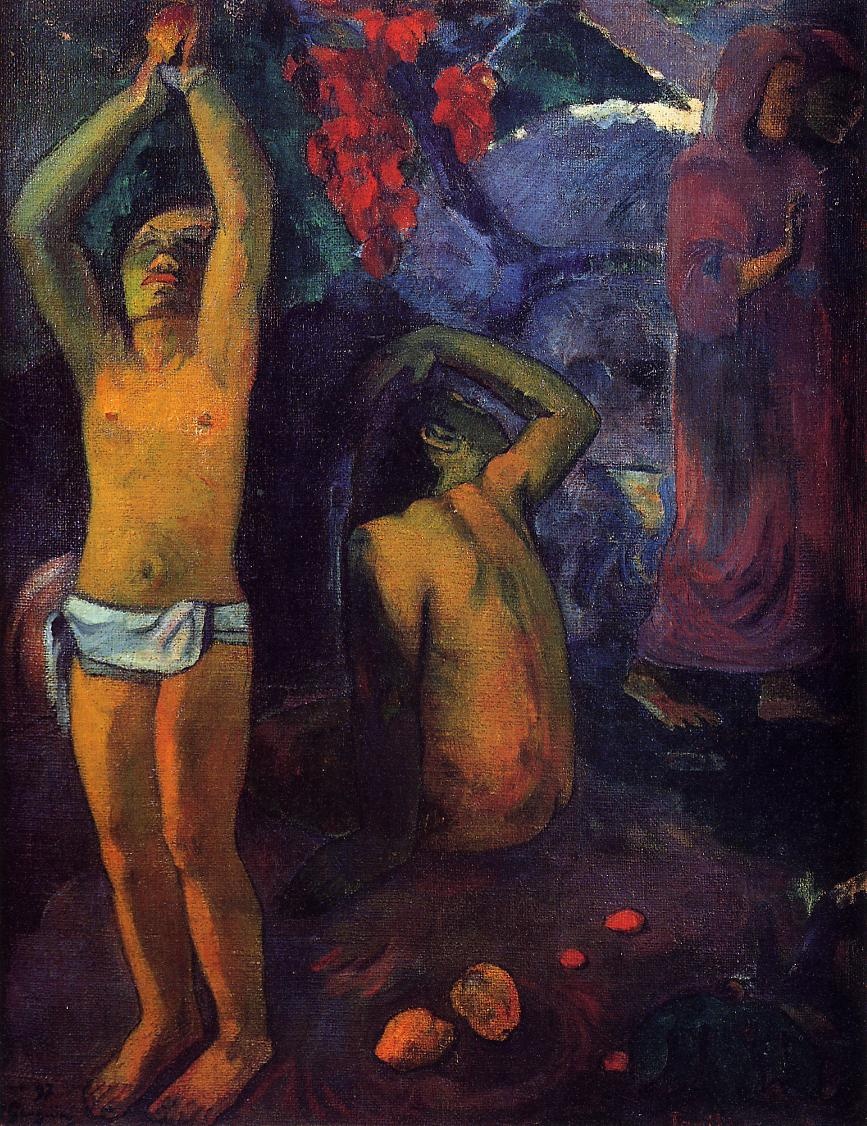Write a detailed description of the given image. The image is an oil painting by Paul Gauguin, a renowned post-impressionist artist. The painting, titled "Where Do We Come From? What Are We? Where Are We Going?", is a profound commentary on the human condition and the meaning of life.

The painting depicts a tropical landscape inhabited by three figures: a man, a woman, and a child. The man stands with his arms raised, perhaps in a gesture of questioning or exclamation. The woman kneels, possibly in a posture of contemplation or prayer. The child stands with their back to the viewer, adding an element of mystery to the scene.

The colors used in the painting are predominantly dark and earthy, creating a sense of depth and richness. This is contrasted by the bright red flowers in the background, which add a vibrant splash of color to the otherwise muted palette.

The painting's style is characteristic of Gauguin's post-impressionist period, with its emphasis on bold colors, distinctive brushwork, and symbolic subject matter. Despite its apparent simplicity, the painting is filled with complex symbolism and deep philosophical questions, making it a fascinating piece of art to contemplate. 